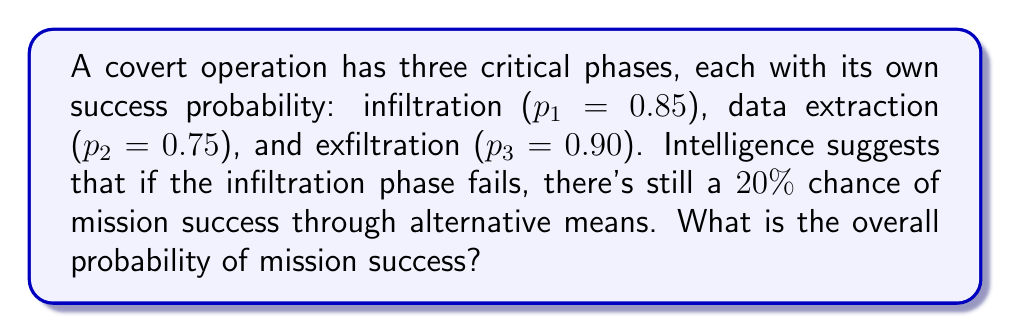Could you help me with this problem? Let's approach this step-by-step:

1) First, let's calculate the probability of success through the primary path:
   $$P(\text{primary success}) = p_1 \cdot p_2 \cdot p_3 = 0.85 \cdot 0.75 \cdot 0.90 = 0.57375$$

2) Now, let's calculate the probability of failure in the infiltration phase:
   $$P(\text{infiltration failure}) = 1 - p_1 = 1 - 0.85 = 0.15$$

3) Given that there's a 20% chance of success if infiltration fails:
   $$P(\text{success | infiltration failure}) = 0.20$$

4) The probability of success through the alternative path is:
   $$P(\text{alternative success}) = P(\text{infiltration failure}) \cdot P(\text{success | infiltration failure})$$
   $$= 0.15 \cdot 0.20 = 0.03$$

5) The overall probability of success is the sum of the probabilities of success through the primary path and the alternative path:
   $$P(\text{overall success}) = P(\text{primary success}) + P(\text{alternative success})$$
   $$= 0.57375 + 0.03 = 0.60375$$

Therefore, the overall probability of mission success is approximately 0.6038 or 60.38%.
Answer: $0.6038$ 